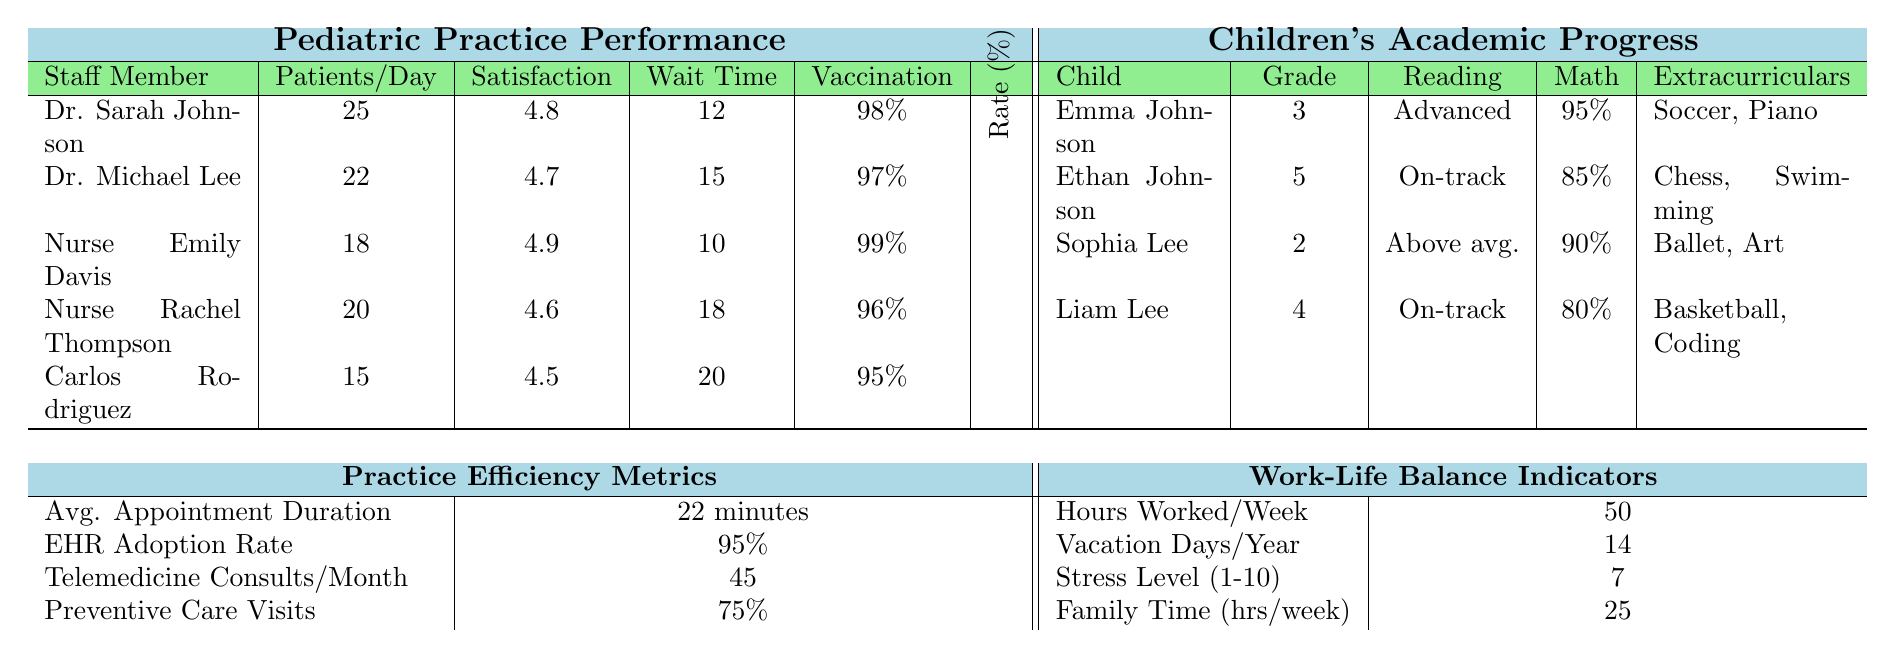What is the patient satisfaction score for Nurse Emily Davis? The table shows the patient satisfaction scores for each staff member. Nurse Emily Davis has a score of 4.9.
Answer: 4.9 Which staff member sees the most patients per day? By looking at the "Patients/Day" column, Dr. Sarah Johnson sees the most patients, with a total of 25 patients daily.
Answer: Dr. Sarah Johnson What is the average wait time for patients? To find the average wait time, add the wait times (12 + 15 + 10 + 18 + 20 = 75) and divide by the number of staff members (5). This gives an average wait time of 75 / 5 = 15 minutes.
Answer: 15 minutes Is the vaccination rate for Dr. Sarah Johnson higher than 97%? Dr. Sarah Johnson has a vaccination rate of 98%, which is indeed higher than 97%.
Answer: Yes Which child has the highest math percentile? Comparing the math percentiles, Emma Johnson has 95%, Ethan Johnson has 85%, Sophia Lee has 90%, and Liam Lee has 80%. Therefore, Emma Johnson has the highest at 95%.
Answer: Emma Johnson What is the total number of extracurricular activities listed for all children? The total can be found by counting the activities: Emma has 2, Ethan has 2, Sophia has 2, and Liam has 2. Adding those gives a total of 8 activities (2 + 2 + 2 + 2 = 8).
Answer: 8 How many vacation days did the staff take on average last year? The vacation days taken by staff are: 14 for each member. To get the average, total the vacation days (14) and divide by the number of staff members (5). This gives an average of 14 days.
Answer: 14 days What was the reading level of the child with the lowest grade level? The child with the lowest grade level is Sophia Lee, who is in grade 2. Her reading level is listed as "Above average."
Answer: Above average Which staff member has the least amount of patients seen per day? The table shows that Carlos Rodriguez sees 15 patients per day, which is the least among all staff members.
Answer: Carlos Rodriguez What is the difference in the average wait time between Nurse Emily Davis and Nurse Rachel Thompson? Nurse Emily Davis has a wait time of 10 minutes, while Nurse Rachel Thompson has 18 minutes. The difference is 18 - 10 = 8 minutes.
Answer: 8 minutes 